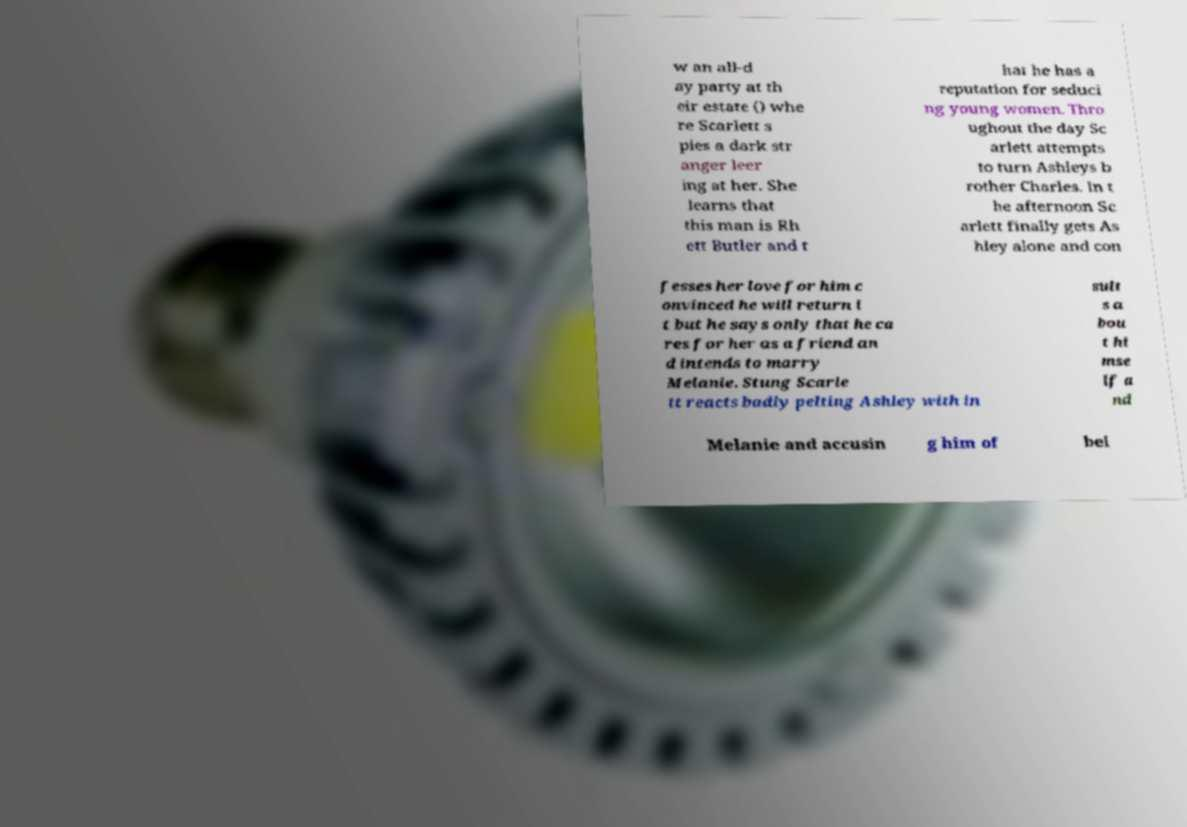Could you assist in decoding the text presented in this image and type it out clearly? w an all-d ay party at th eir estate () whe re Scarlett s pies a dark str anger leer ing at her. She learns that this man is Rh ett Butler and t hat he has a reputation for seduci ng young women. Thro ughout the day Sc arlett attempts to turn Ashleys b rother Charles. In t he afternoon Sc arlett finally gets As hley alone and con fesses her love for him c onvinced he will return i t but he says only that he ca res for her as a friend an d intends to marry Melanie. Stung Scarle tt reacts badly pelting Ashley with in sult s a bou t hi mse lf a nd Melanie and accusin g him of bei 